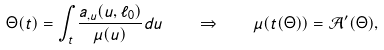Convert formula to latex. <formula><loc_0><loc_0><loc_500><loc_500>\Theta ( t ) = \int _ { t } \frac { a _ { , u } ( u , \ell _ { 0 } ) } { \mu ( u ) } d u \quad \Rightarrow \quad \mu ( t ( \Theta ) ) = { \mathcal { A } } ^ { \prime } ( \Theta ) ,</formula> 